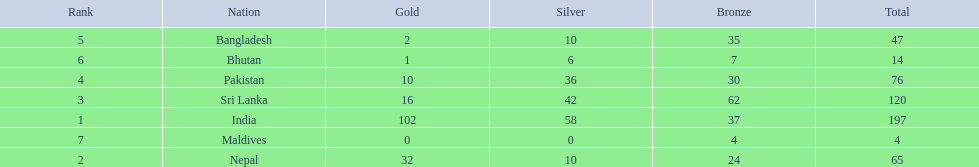How many gold medals were won by the teams? 102, 32, 16, 10, 2, 1, 0. What country won no gold medals? Maldives. 